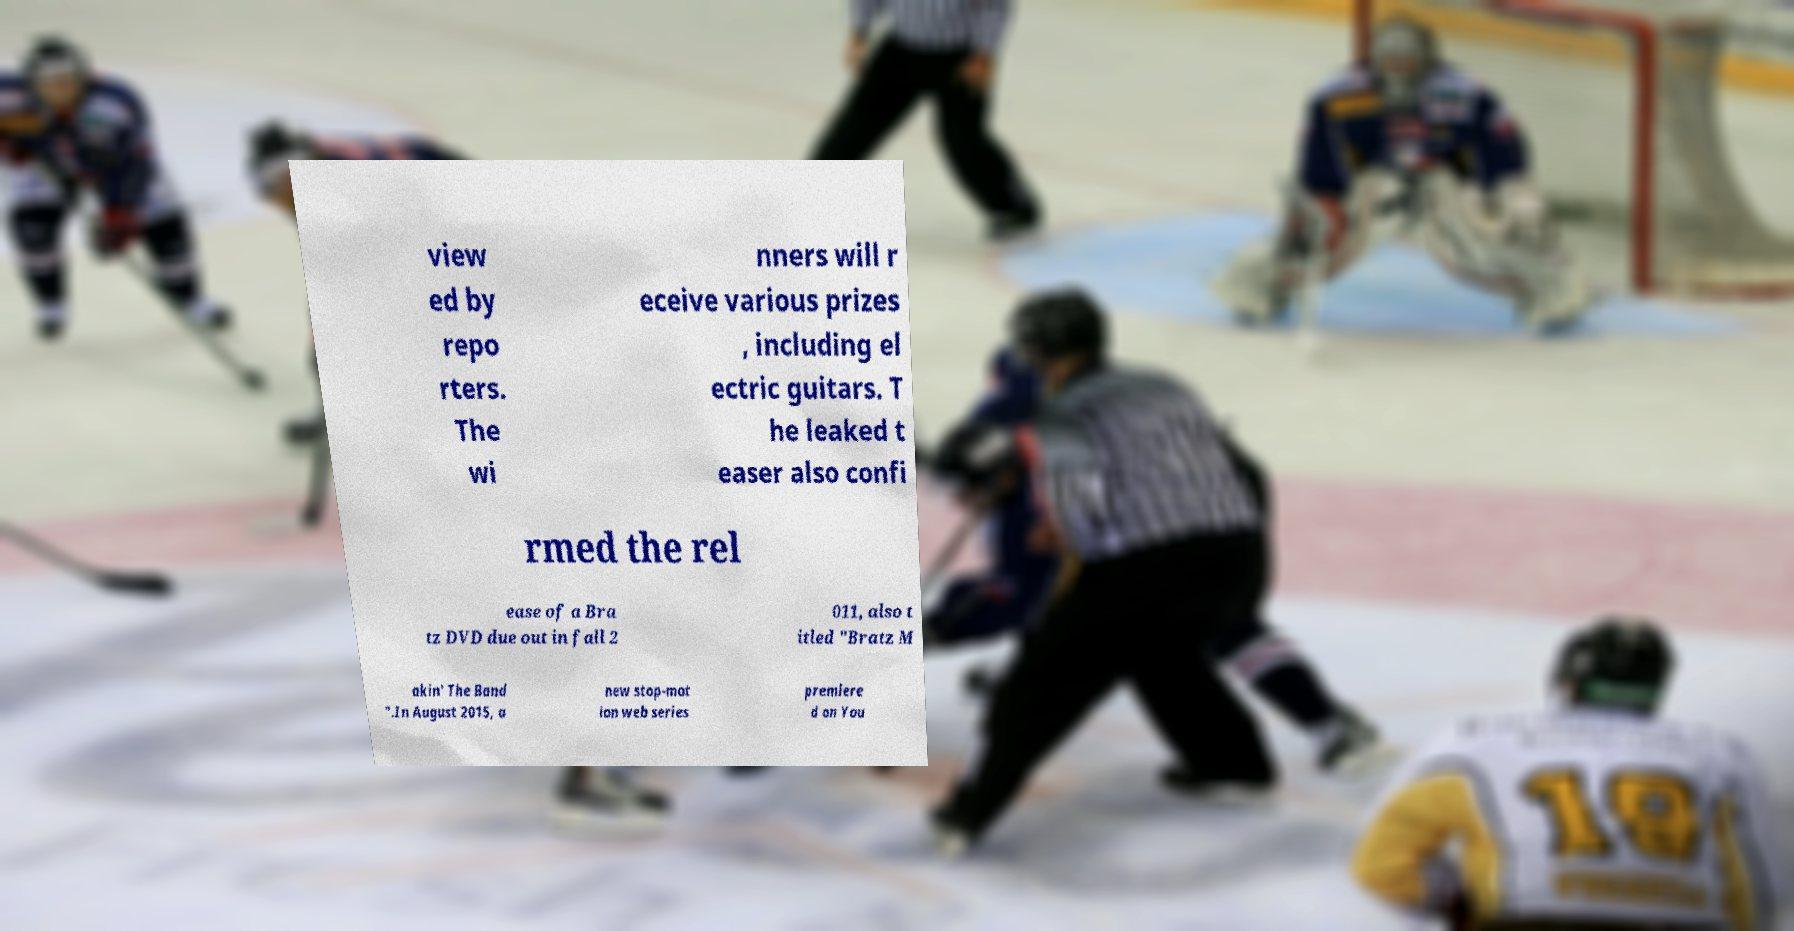For documentation purposes, I need the text within this image transcribed. Could you provide that? view ed by repo rters. The wi nners will r eceive various prizes , including el ectric guitars. T he leaked t easer also confi rmed the rel ease of a Bra tz DVD due out in fall 2 011, also t itled "Bratz M akin' The Band ".In August 2015, a new stop-mot ion web series premiere d on You 